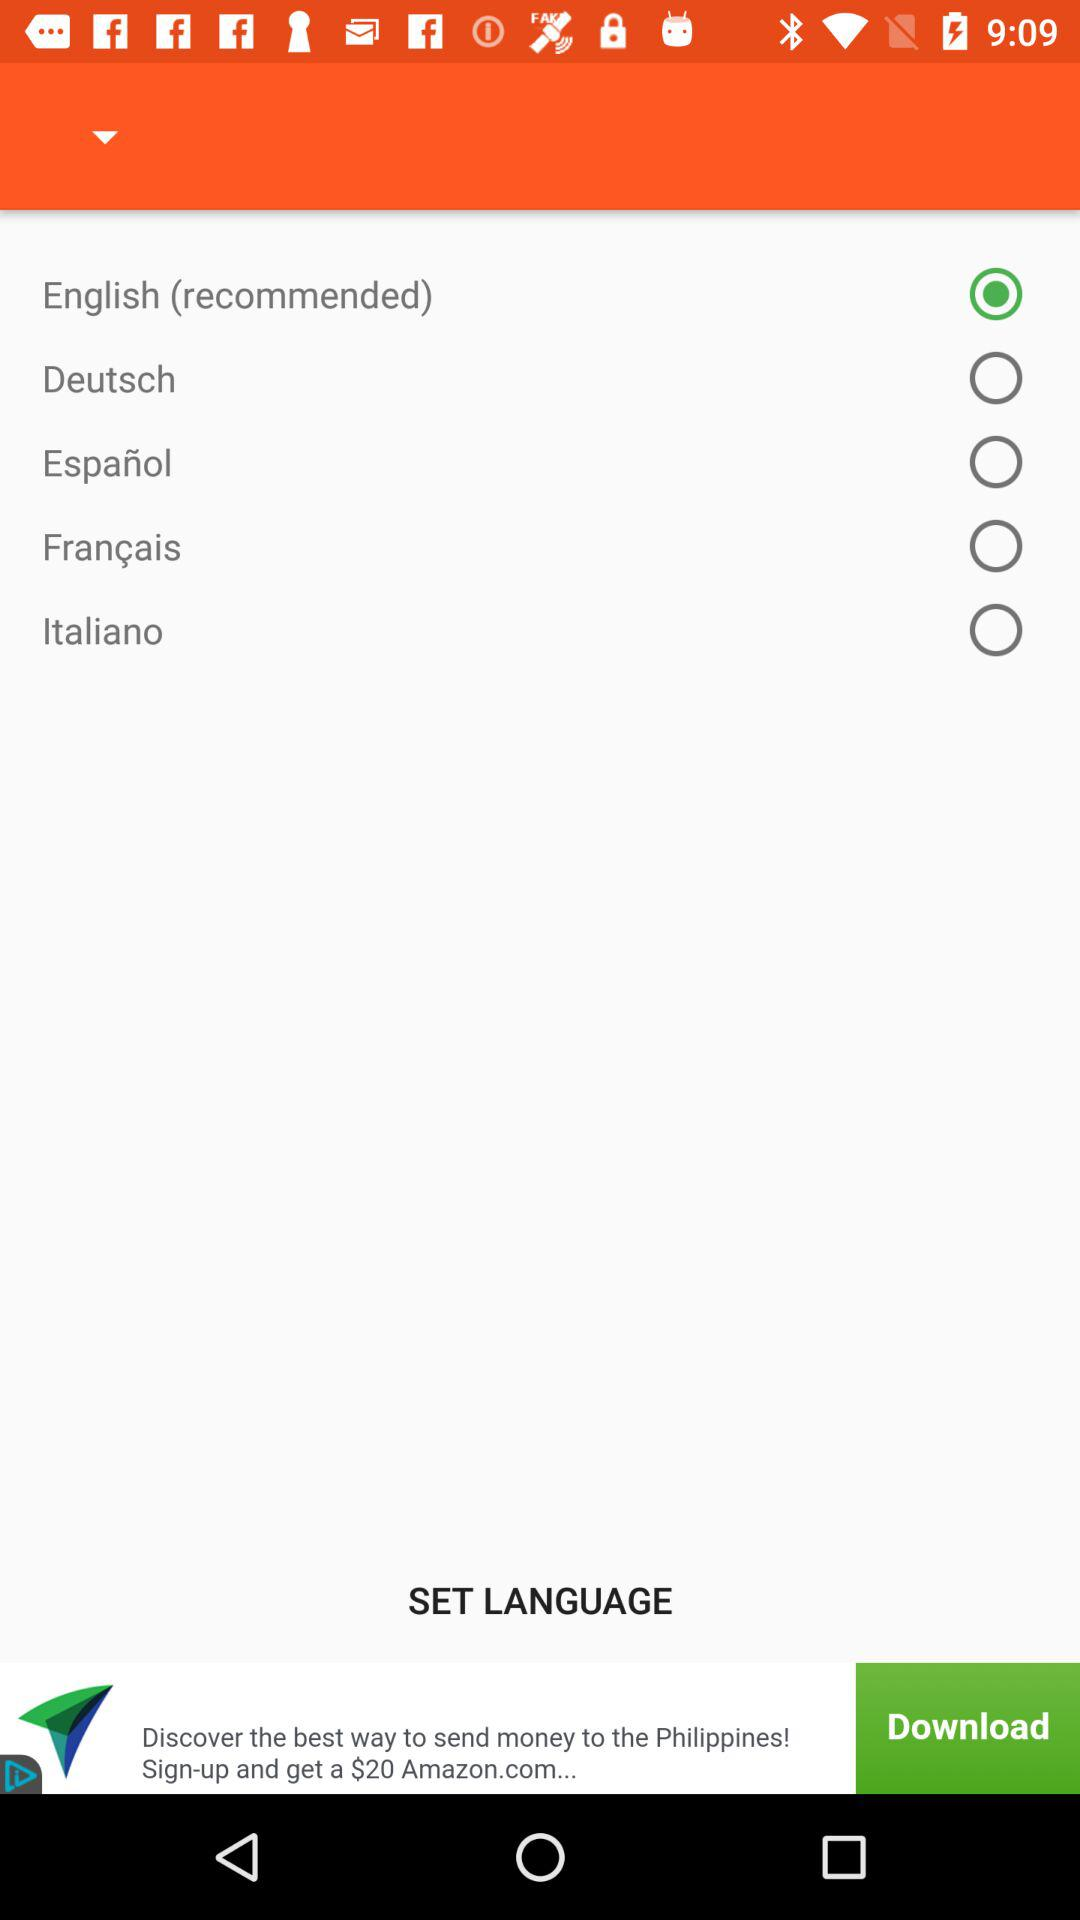How many languages are available for selection?
Answer the question using a single word or phrase. 5 